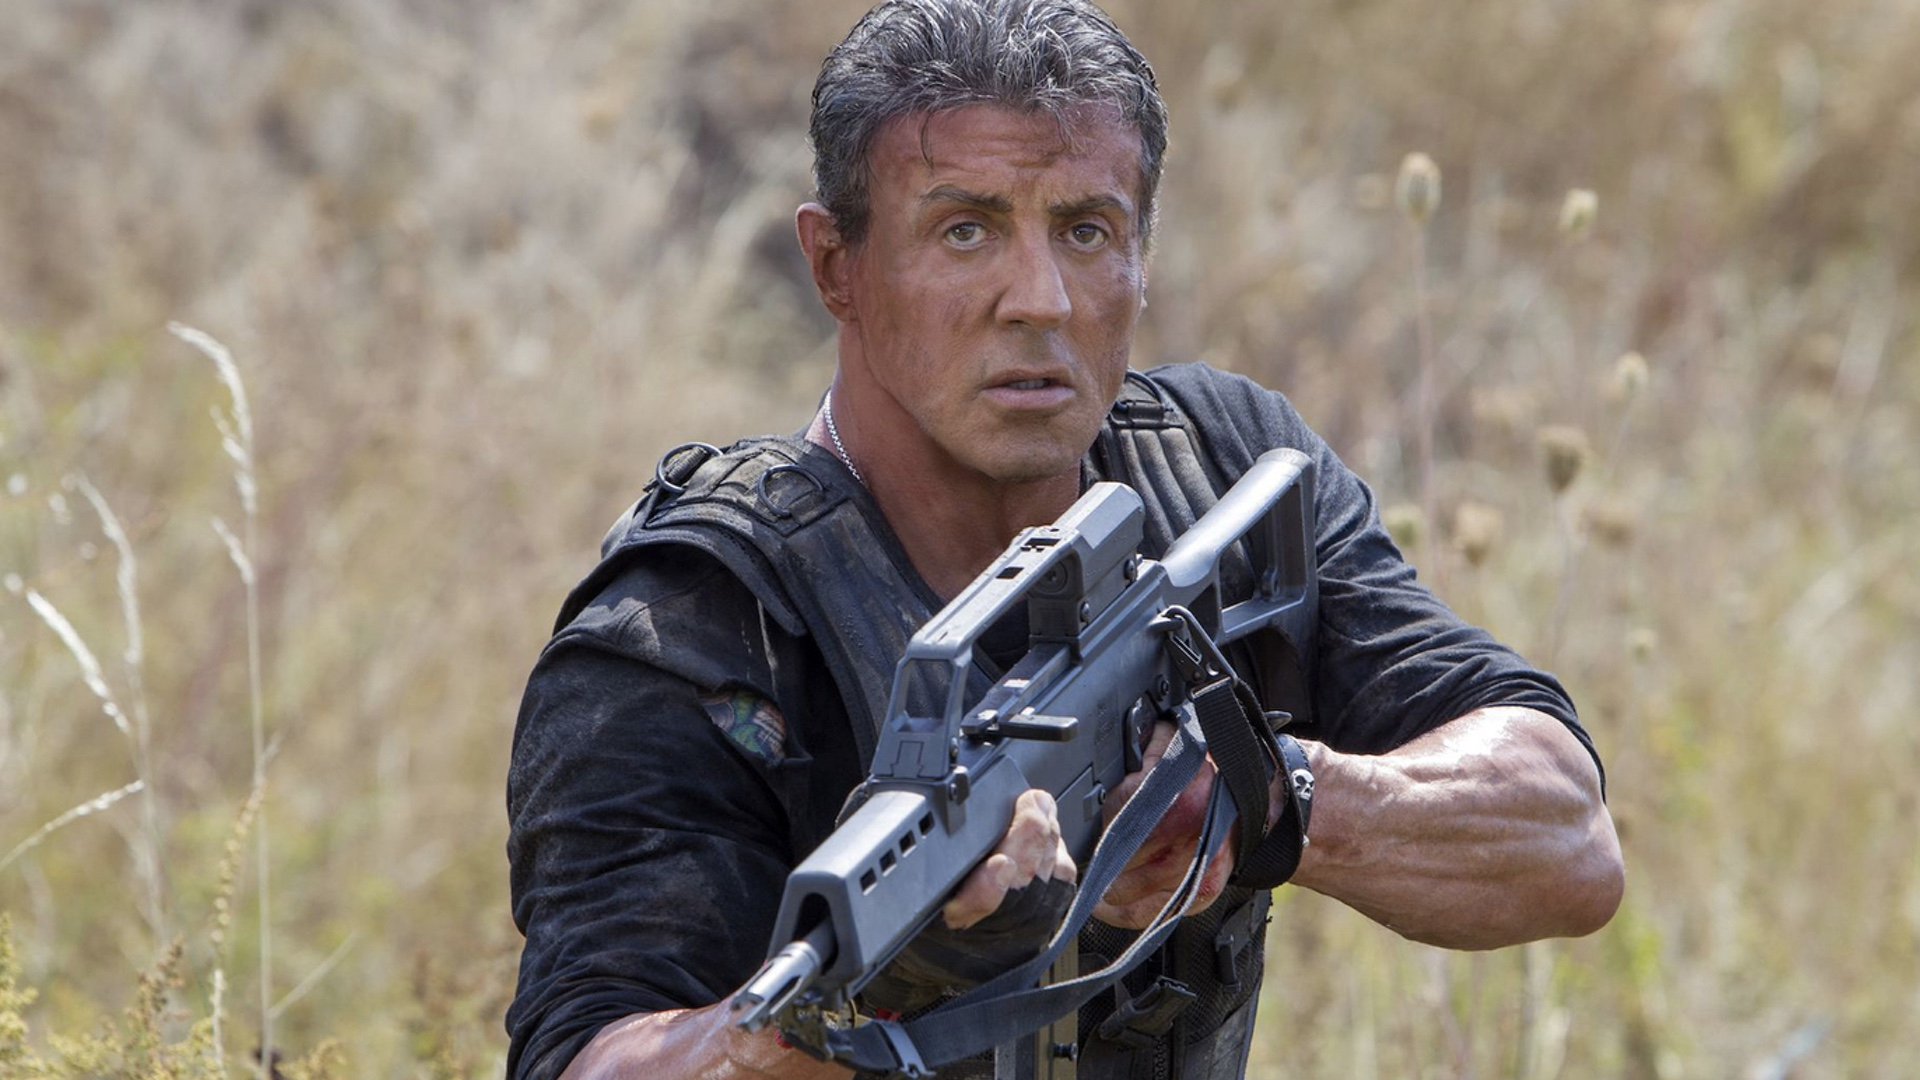Describe the emotional state of John Rambo in this image. John Rambo's emotional state in this image appears to be one of intense vigilance and determination. His furrowed brow and unwavering gaze indicate that he is mentally prepared for a serious confrontation. There's a blend of focused aggression and stoic resolve in his demeanor, reflecting the gravity of the situation he finds himself in. 